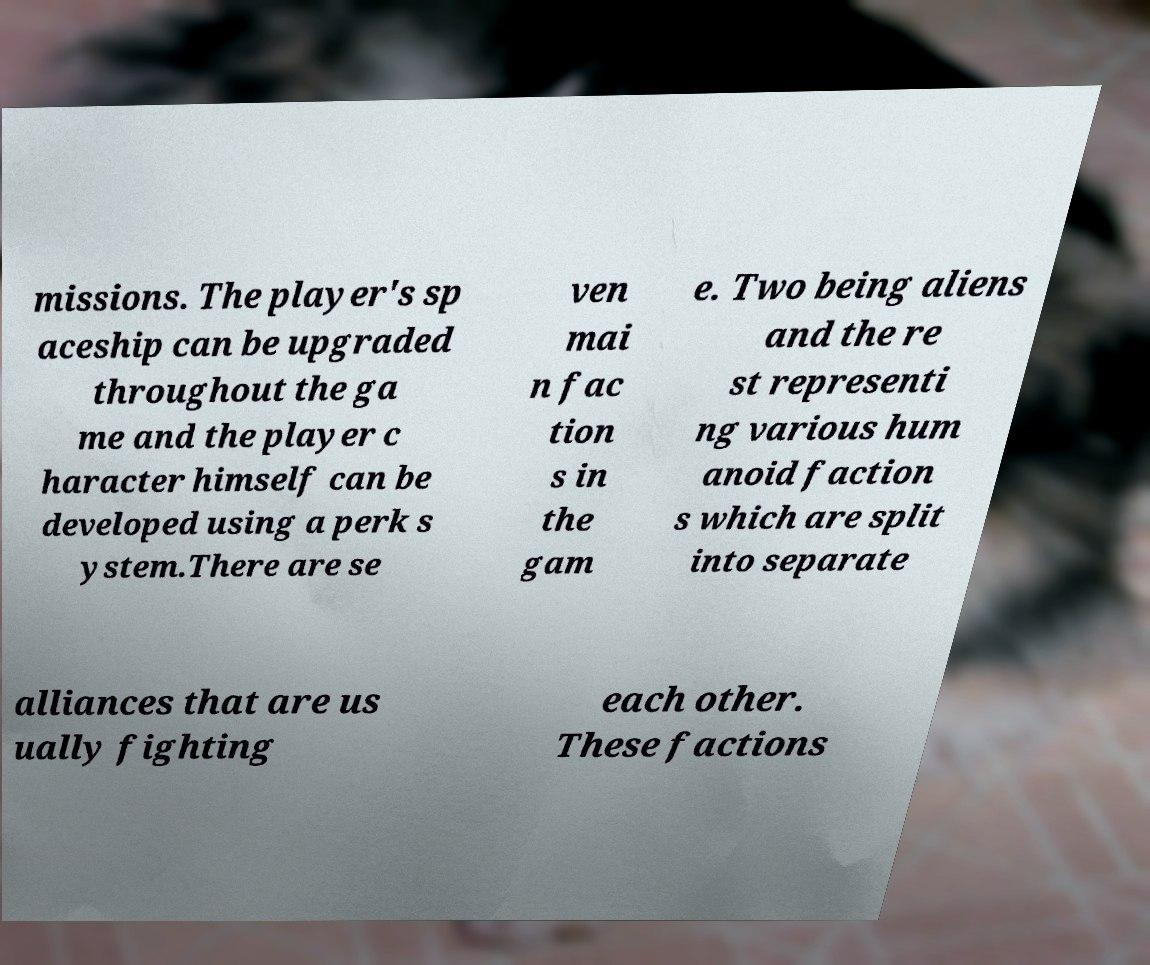What messages or text are displayed in this image? I need them in a readable, typed format. missions. The player's sp aceship can be upgraded throughout the ga me and the player c haracter himself can be developed using a perk s ystem.There are se ven mai n fac tion s in the gam e. Two being aliens and the re st representi ng various hum anoid faction s which are split into separate alliances that are us ually fighting each other. These factions 